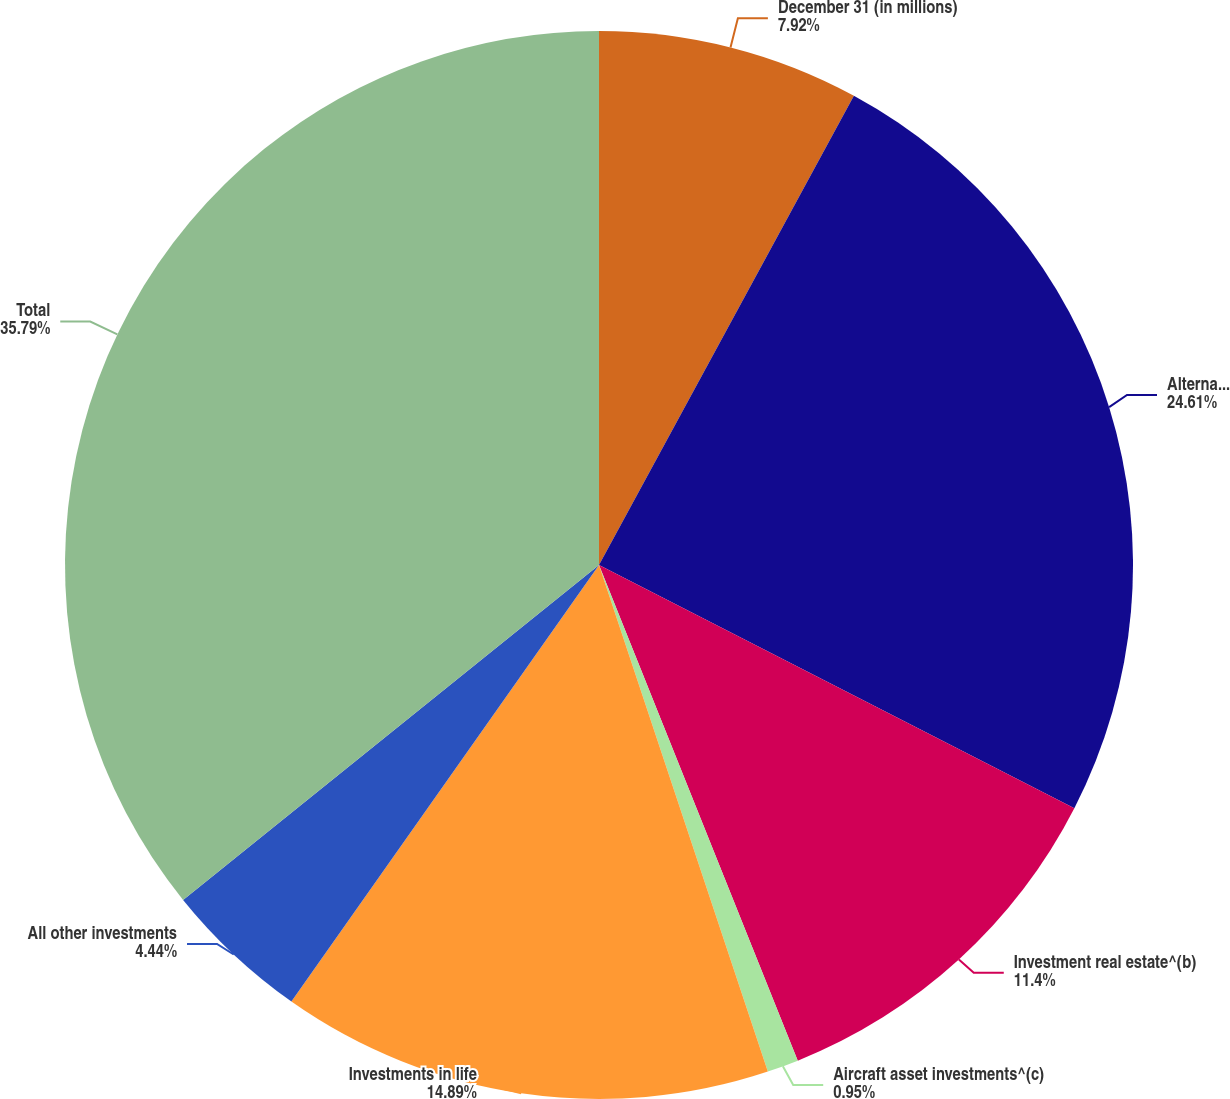Convert chart. <chart><loc_0><loc_0><loc_500><loc_500><pie_chart><fcel>December 31 (in millions)<fcel>Alternative investments^(a)<fcel>Investment real estate^(b)<fcel>Aircraft asset investments^(c)<fcel>Investments in life<fcel>All other investments<fcel>Total<nl><fcel>7.92%<fcel>24.61%<fcel>11.4%<fcel>0.95%<fcel>14.89%<fcel>4.44%<fcel>35.79%<nl></chart> 